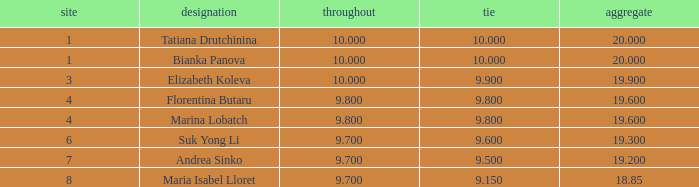What place had a ribbon below 9.8 and a 19.2 total? 7.0. 